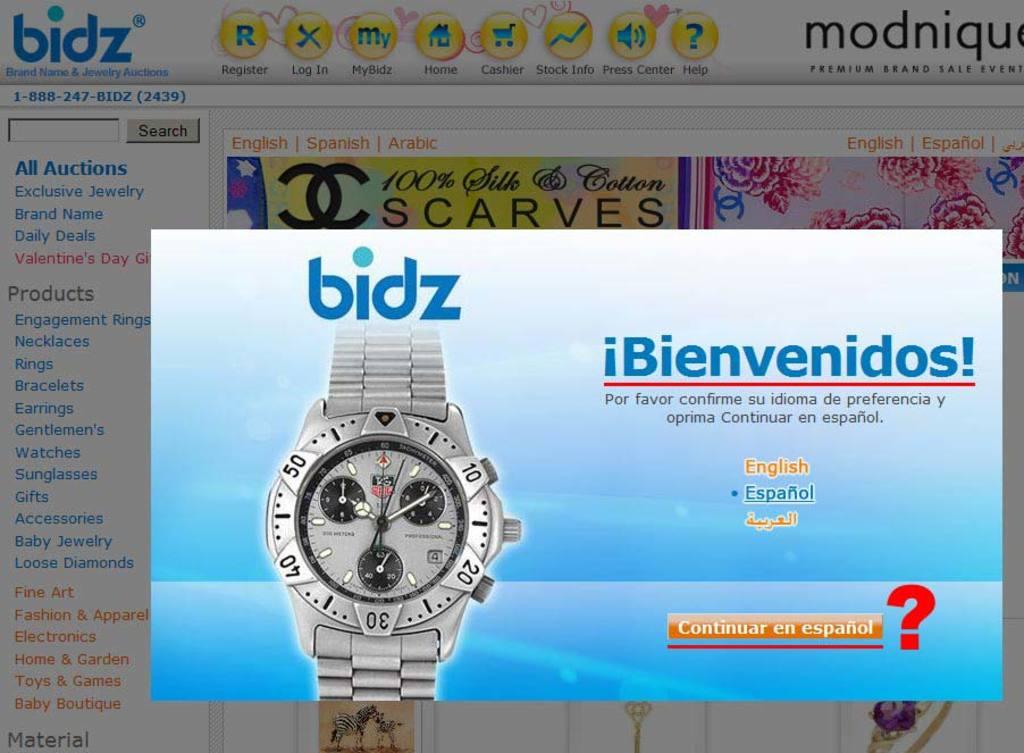What auction website is advertised here?
Your response must be concise. Bidz. What languages is this website in?
Your response must be concise. Spanish. 